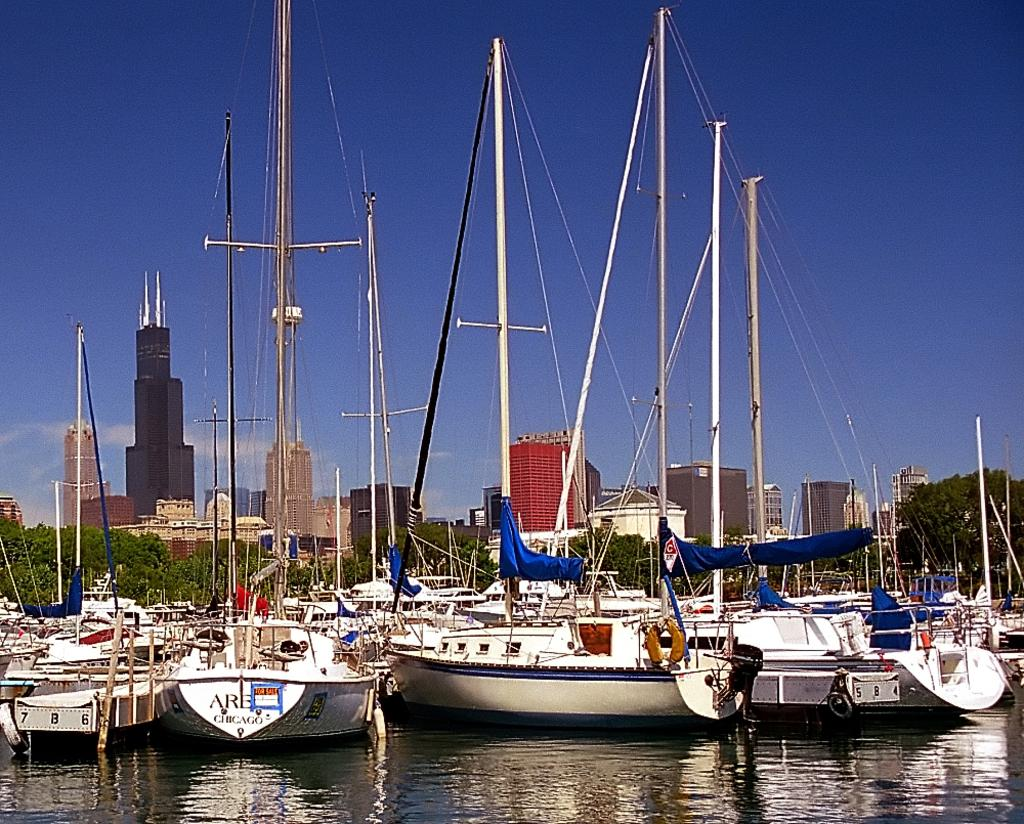<image>
Share a concise interpretation of the image provided. A body of water is holding boats securely not in use, one of them has CHICAGO on it. 